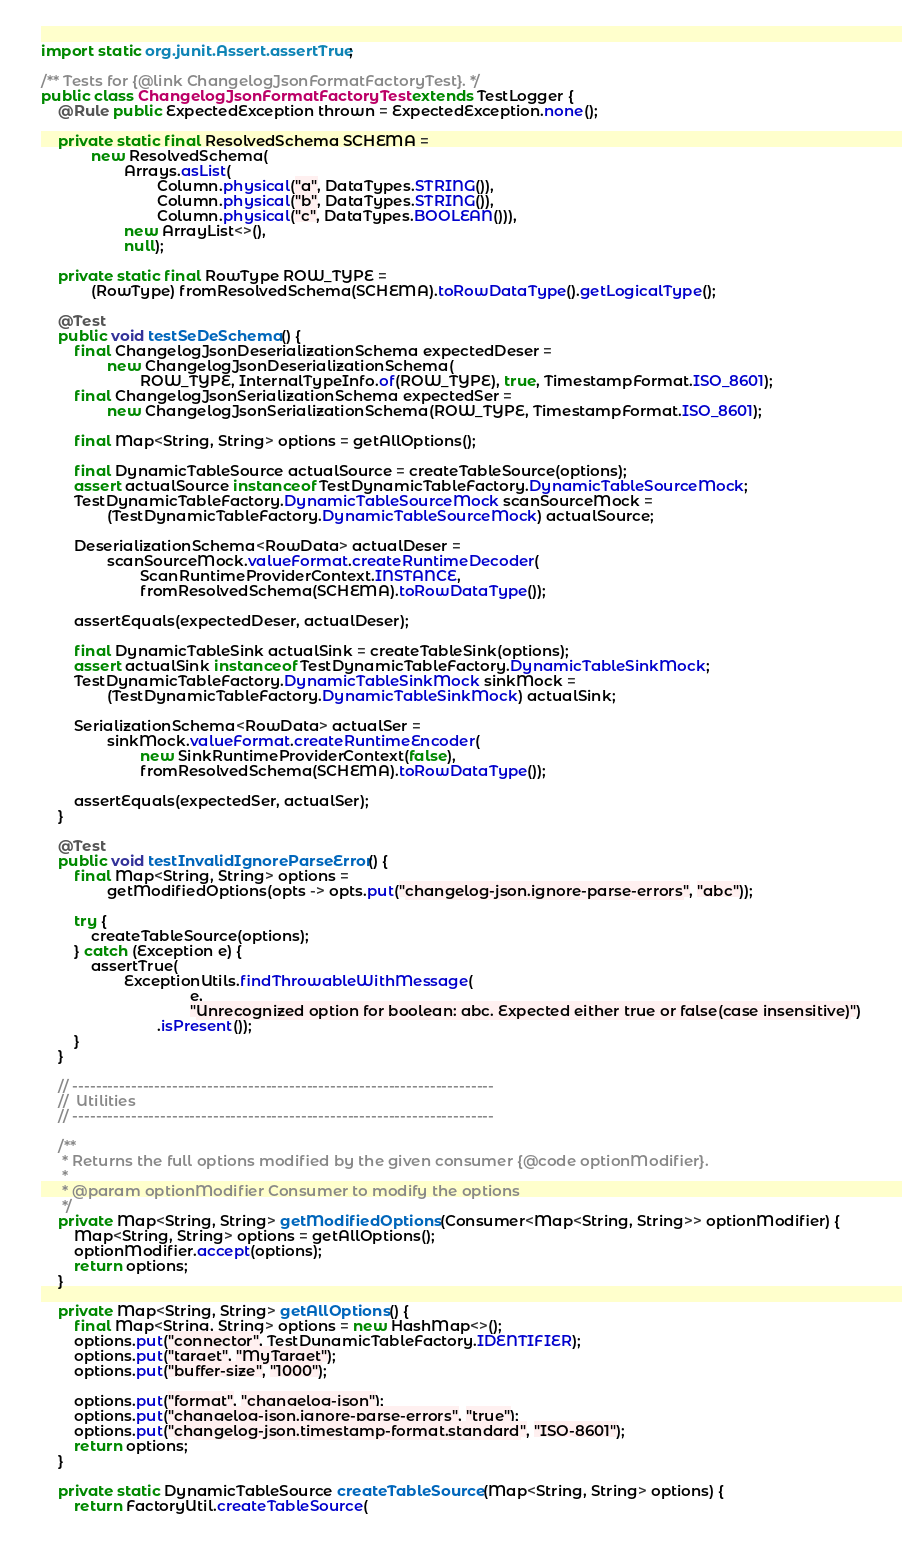<code> <loc_0><loc_0><loc_500><loc_500><_Java_>import static org.junit.Assert.assertTrue;

/** Tests for {@link ChangelogJsonFormatFactoryTest}. */
public class ChangelogJsonFormatFactoryTest extends TestLogger {
    @Rule public ExpectedException thrown = ExpectedException.none();

    private static final ResolvedSchema SCHEMA =
            new ResolvedSchema(
                    Arrays.asList(
                            Column.physical("a", DataTypes.STRING()),
                            Column.physical("b", DataTypes.STRING()),
                            Column.physical("c", DataTypes.BOOLEAN())),
                    new ArrayList<>(),
                    null);

    private static final RowType ROW_TYPE =
            (RowType) fromResolvedSchema(SCHEMA).toRowDataType().getLogicalType();

    @Test
    public void testSeDeSchema() {
        final ChangelogJsonDeserializationSchema expectedDeser =
                new ChangelogJsonDeserializationSchema(
                        ROW_TYPE, InternalTypeInfo.of(ROW_TYPE), true, TimestampFormat.ISO_8601);
        final ChangelogJsonSerializationSchema expectedSer =
                new ChangelogJsonSerializationSchema(ROW_TYPE, TimestampFormat.ISO_8601);

        final Map<String, String> options = getAllOptions();

        final DynamicTableSource actualSource = createTableSource(options);
        assert actualSource instanceof TestDynamicTableFactory.DynamicTableSourceMock;
        TestDynamicTableFactory.DynamicTableSourceMock scanSourceMock =
                (TestDynamicTableFactory.DynamicTableSourceMock) actualSource;

        DeserializationSchema<RowData> actualDeser =
                scanSourceMock.valueFormat.createRuntimeDecoder(
                        ScanRuntimeProviderContext.INSTANCE,
                        fromResolvedSchema(SCHEMA).toRowDataType());

        assertEquals(expectedDeser, actualDeser);

        final DynamicTableSink actualSink = createTableSink(options);
        assert actualSink instanceof TestDynamicTableFactory.DynamicTableSinkMock;
        TestDynamicTableFactory.DynamicTableSinkMock sinkMock =
                (TestDynamicTableFactory.DynamicTableSinkMock) actualSink;

        SerializationSchema<RowData> actualSer =
                sinkMock.valueFormat.createRuntimeEncoder(
                        new SinkRuntimeProviderContext(false),
                        fromResolvedSchema(SCHEMA).toRowDataType());

        assertEquals(expectedSer, actualSer);
    }

    @Test
    public void testInvalidIgnoreParseError() {
        final Map<String, String> options =
                getModifiedOptions(opts -> opts.put("changelog-json.ignore-parse-errors", "abc"));

        try {
            createTableSource(options);
        } catch (Exception e) {
            assertTrue(
                    ExceptionUtils.findThrowableWithMessage(
                                    e,
                                    "Unrecognized option for boolean: abc. Expected either true or false(case insensitive)")
                            .isPresent());
        }
    }

    // ------------------------------------------------------------------------
    //  Utilities
    // ------------------------------------------------------------------------

    /**
     * Returns the full options modified by the given consumer {@code optionModifier}.
     *
     * @param optionModifier Consumer to modify the options
     */
    private Map<String, String> getModifiedOptions(Consumer<Map<String, String>> optionModifier) {
        Map<String, String> options = getAllOptions();
        optionModifier.accept(options);
        return options;
    }

    private Map<String, String> getAllOptions() {
        final Map<String, String> options = new HashMap<>();
        options.put("connector", TestDynamicTableFactory.IDENTIFIER);
        options.put("target", "MyTarget");
        options.put("buffer-size", "1000");

        options.put("format", "changelog-json");
        options.put("changelog-json.ignore-parse-errors", "true");
        options.put("changelog-json.timestamp-format.standard", "ISO-8601");
        return options;
    }

    private static DynamicTableSource createTableSource(Map<String, String> options) {
        return FactoryUtil.createTableSource(</code> 